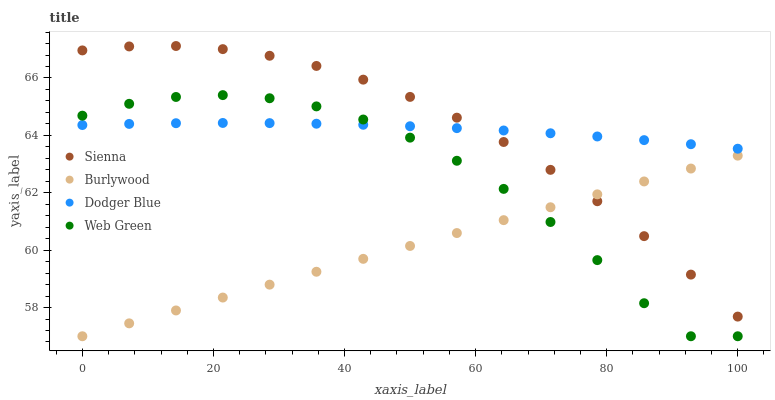Does Burlywood have the minimum area under the curve?
Answer yes or no. Yes. Does Sienna have the maximum area under the curve?
Answer yes or no. Yes. Does Dodger Blue have the minimum area under the curve?
Answer yes or no. No. Does Dodger Blue have the maximum area under the curve?
Answer yes or no. No. Is Burlywood the smoothest?
Answer yes or no. Yes. Is Web Green the roughest?
Answer yes or no. Yes. Is Dodger Blue the smoothest?
Answer yes or no. No. Is Dodger Blue the roughest?
Answer yes or no. No. Does Burlywood have the lowest value?
Answer yes or no. Yes. Does Dodger Blue have the lowest value?
Answer yes or no. No. Does Sienna have the highest value?
Answer yes or no. Yes. Does Dodger Blue have the highest value?
Answer yes or no. No. Is Web Green less than Sienna?
Answer yes or no. Yes. Is Sienna greater than Web Green?
Answer yes or no. Yes. Does Sienna intersect Burlywood?
Answer yes or no. Yes. Is Sienna less than Burlywood?
Answer yes or no. No. Is Sienna greater than Burlywood?
Answer yes or no. No. Does Web Green intersect Sienna?
Answer yes or no. No. 